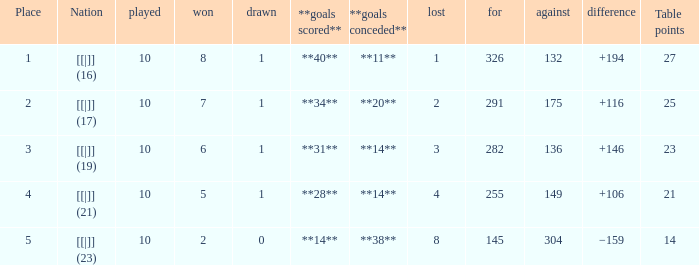 How many games had a deficit of 175?  1.0. 